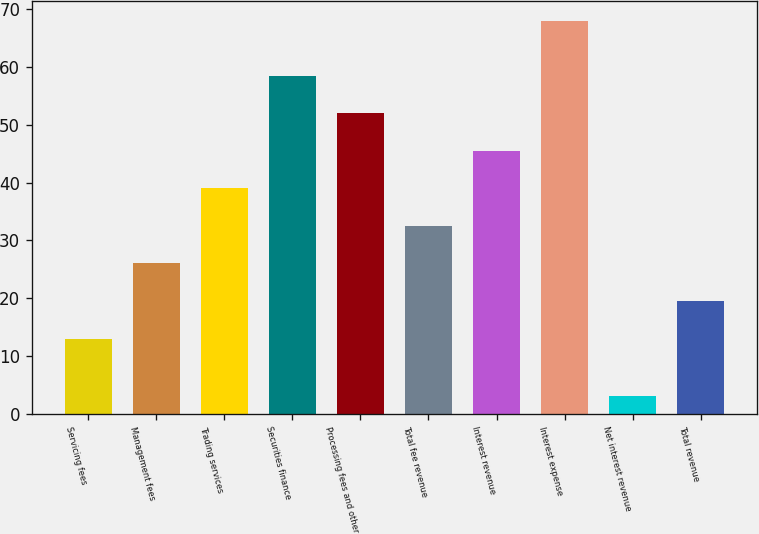Convert chart. <chart><loc_0><loc_0><loc_500><loc_500><bar_chart><fcel>Servicing fees<fcel>Management fees<fcel>Trading services<fcel>Securities finance<fcel>Processing fees and other<fcel>Total fee revenue<fcel>Interest revenue<fcel>Interest expense<fcel>Net interest revenue<fcel>Total revenue<nl><fcel>13<fcel>26<fcel>39<fcel>58.5<fcel>52<fcel>32.5<fcel>45.5<fcel>68<fcel>3<fcel>19.5<nl></chart> 